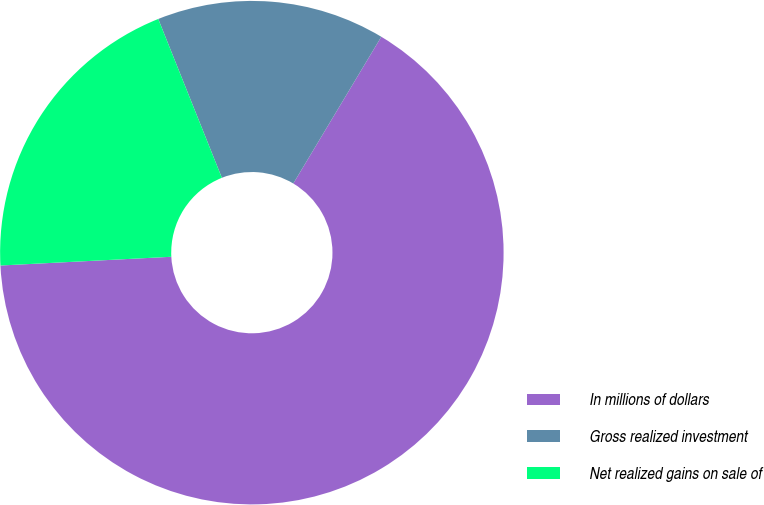Convert chart to OTSL. <chart><loc_0><loc_0><loc_500><loc_500><pie_chart><fcel>In millions of dollars<fcel>Gross realized investment<fcel>Net realized gains on sale of<nl><fcel>65.59%<fcel>14.66%<fcel>19.75%<nl></chart> 